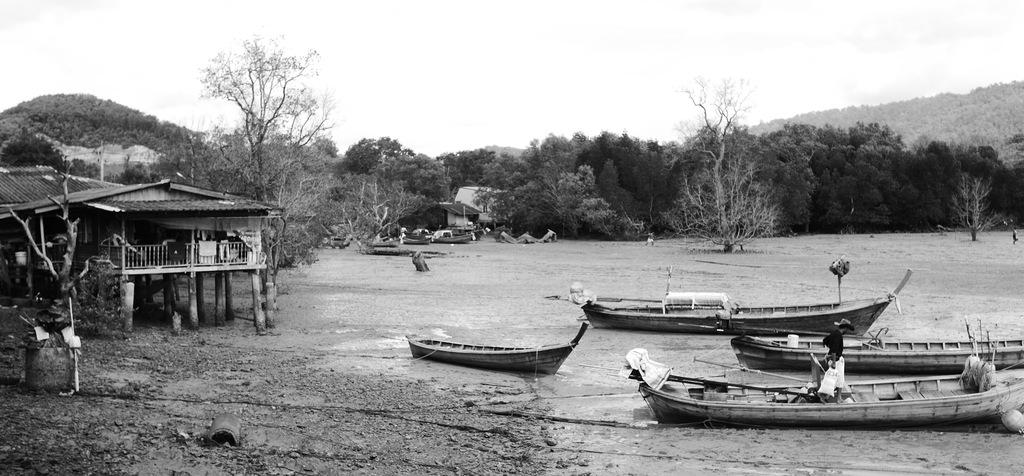What is the color scheme of the image? The image is black and white. What is located above the water in the image? There are boats above the water in the image. What type of structure can be seen in the image? There is a house in the image. What can be seen in the background of the image? There are trees, another house, and the sky visible in the background of the image. What type of horse-related apparatus is present in the image? There is no horse or apparatus related to horses present in the image. What date is shown on the calendar in the image? There is no calendar present in the image. 